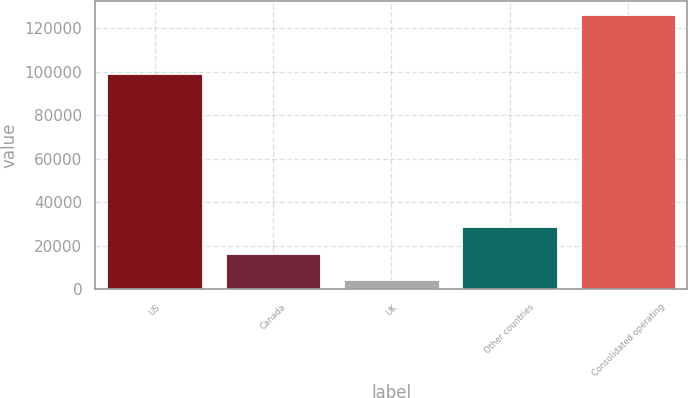Convert chart to OTSL. <chart><loc_0><loc_0><loc_500><loc_500><bar_chart><fcel>US<fcel>Canada<fcel>UK<fcel>Other countries<fcel>Consolidated operating<nl><fcel>98806<fcel>16466<fcel>4297<fcel>28635<fcel>125987<nl></chart> 